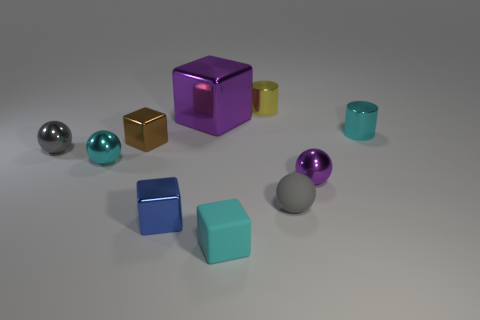There is a thing that is both left of the large purple metal block and behind the small gray metal object; what is its shape? The object that is situated to the left of the large purple metal block and behind the small gray metal object is a cube. More specifically, it's a blue cube which has a lighter shade compared to the large purple block and features distinct, sharp edges characteristic of a cubic shape. 